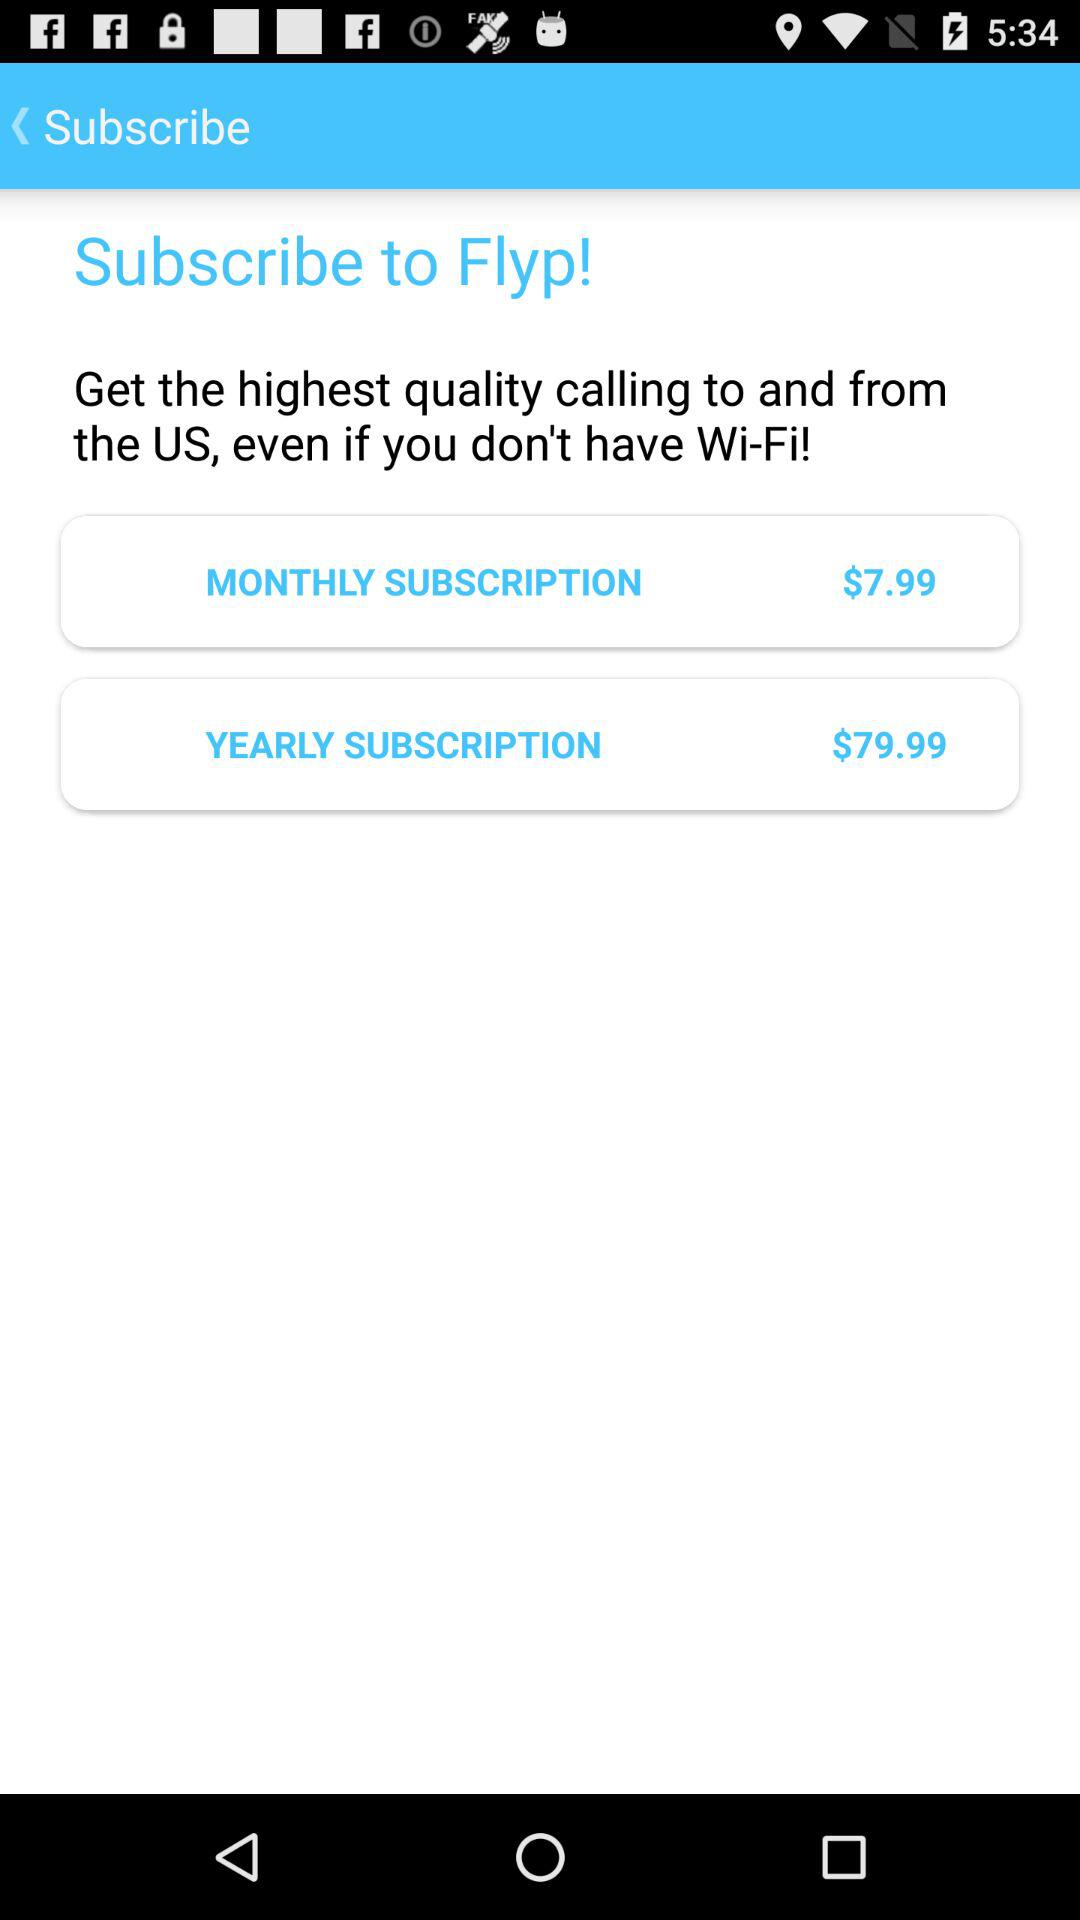How much more does the yearly subscription cost than the monthly subscription?
Answer the question using a single word or phrase. $72 